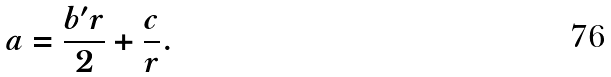Convert formula to latex. <formula><loc_0><loc_0><loc_500><loc_500>a = \frac { b ^ { \prime } r } { 2 } + \frac { c } { r } .</formula> 